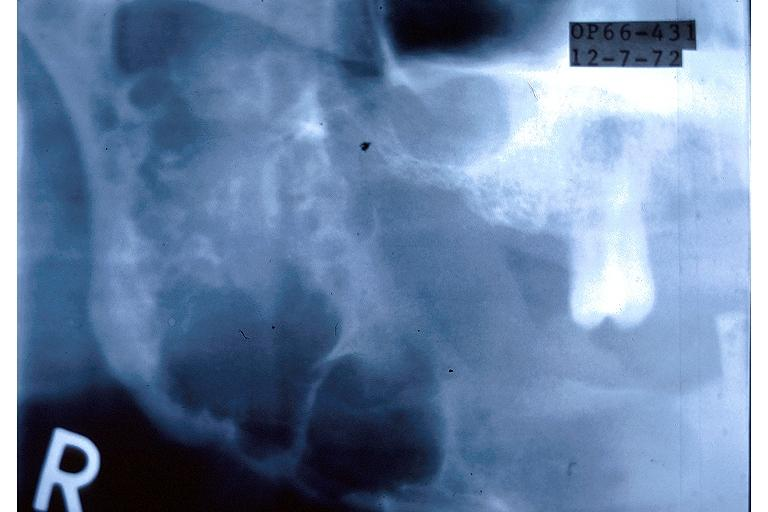does this image show ameloblastoma?
Answer the question using a single word or phrase. Yes 